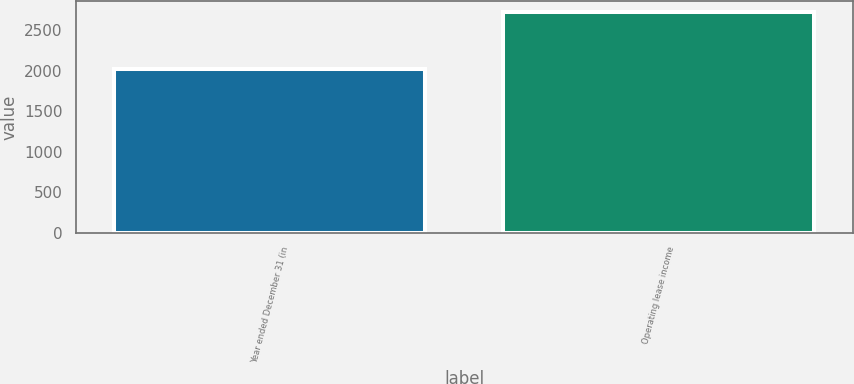<chart> <loc_0><loc_0><loc_500><loc_500><bar_chart><fcel>Year ended December 31 (in<fcel>Operating lease income<nl><fcel>2016<fcel>2724<nl></chart> 